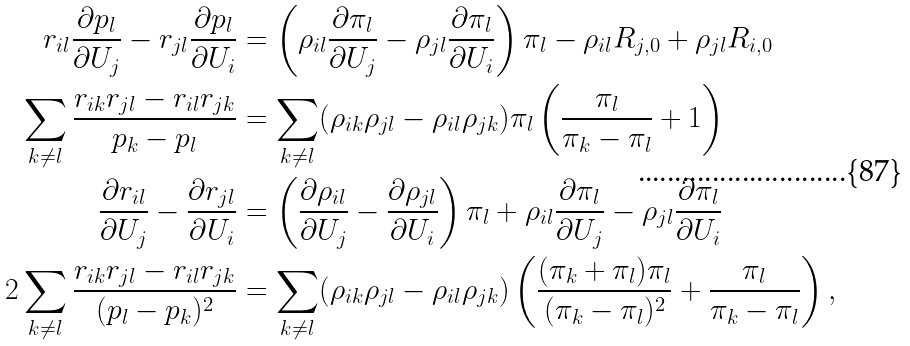Convert formula to latex. <formula><loc_0><loc_0><loc_500><loc_500>r _ { i l } \frac { \partial p _ { l } } { \partial U _ { j } } - r _ { j l } \frac { \partial p _ { l } } { \partial U _ { i } } & = \left ( \rho _ { i l } \frac { \partial \pi _ { l } } { \partial U _ { j } } - \rho _ { j l } \frac { \partial \pi _ { l } } { \partial U _ { i } } \right ) \pi _ { l } - \rho _ { i l } R _ { j , 0 } + \rho _ { j l } R _ { i , 0 } \\ \sum _ { k \neq l } \frac { r _ { i k } r _ { j l } - r _ { i l } r _ { j k } } { p _ { k } - p _ { l } } & = \sum _ { k \neq l } ( \rho _ { i k } \rho _ { j l } - \rho _ { i l } \rho _ { j k } ) \pi _ { l } \left ( \frac { \pi _ { l } } { \pi _ { k } - \pi _ { l } } + 1 \right ) \\ \frac { \partial r _ { i l } } { \partial U _ { j } } - \frac { \partial r _ { j l } } { \partial U _ { i } } & = \left ( \frac { \partial \rho _ { i l } } { \partial U _ { j } } - \frac { \partial \rho _ { j l } } { \partial U _ { i } } \right ) \pi _ { l } + \rho _ { i l } \frac { \partial \pi _ { l } } { \partial U _ { j } } - \rho _ { j l } \frac { \partial \pi _ { l } } { \partial U _ { i } } \\ 2 \sum _ { k \neq l } \frac { r _ { i k } r _ { j l } - r _ { i l } r _ { j k } } { ( p _ { l } - p _ { k } ) ^ { 2 } } & = \sum _ { k \neq l } ( \rho _ { i k } \rho _ { j l } - \rho _ { i l } \rho _ { j k } ) \left ( \frac { ( \pi _ { k } + \pi _ { l } ) \pi _ { l } } { ( \pi _ { k } - \pi _ { l } ) ^ { 2 } } + \frac { \pi _ { l } } { \pi _ { k } - \pi _ { l } } \right ) ,</formula> 